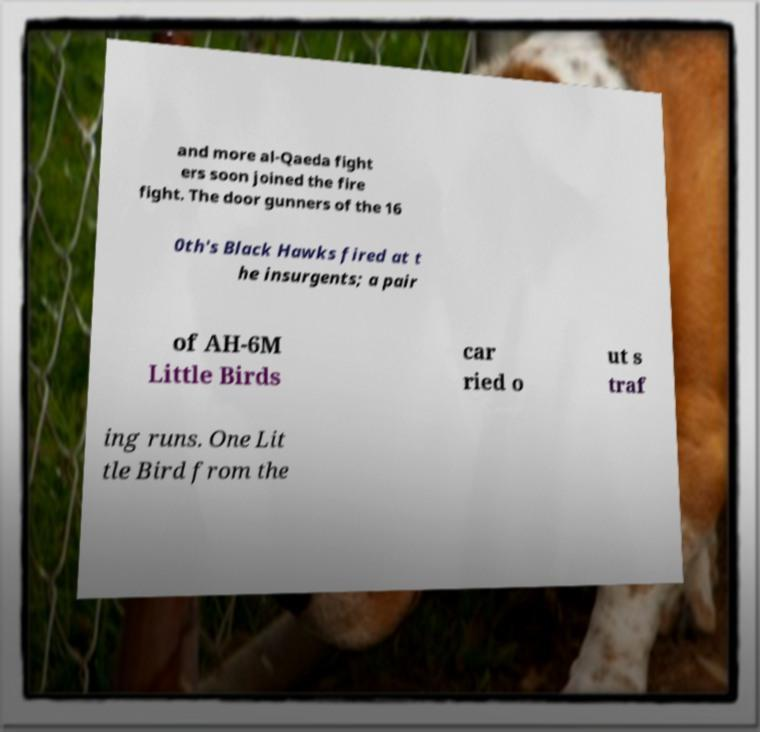There's text embedded in this image that I need extracted. Can you transcribe it verbatim? and more al-Qaeda fight ers soon joined the fire fight. The door gunners of the 16 0th's Black Hawks fired at t he insurgents; a pair of AH-6M Little Birds car ried o ut s traf ing runs. One Lit tle Bird from the 